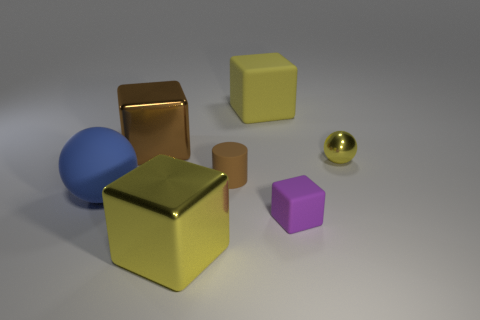What might be the purpose of such an arrangement of objects? This arrangement of objects could serve several purposes. It might be a visual composition created for an artistic purpose, demonstrating how different shapes, colors, and textures interact under a certain lighting condition. Alternatively, it could be part of a 3D modeling or rendering exercise, possibly to showcase the rendering capabilities of a software program by displaying various materials and the effects of light and shadow on them. 